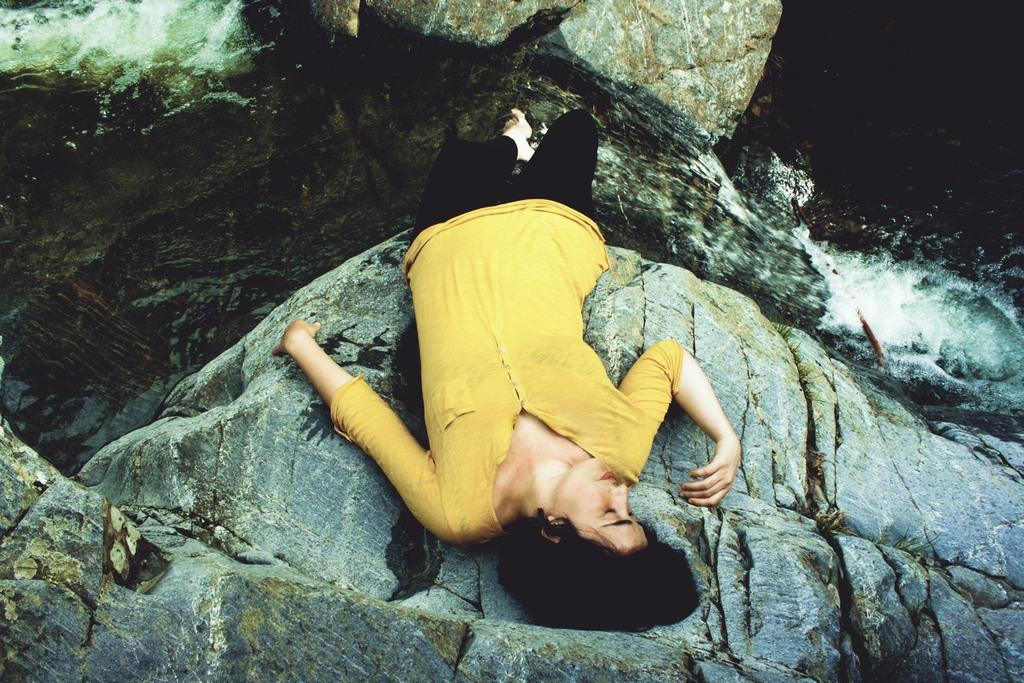Who is the main subject in the image? There is a woman in the image. What is the woman doing in the image? The woman is laying on a rock. What color is the woman's shirt in the image? The woman is wearing a yellow shirt. What color are the woman's pants in the image? The woman is wearing black pants. What can be seen in the background of the image? There is water visible in the image. What type of cough medicine is the woman holding in the image? There is no cough medicine present in the image; the woman is laying on a rock and wearing a yellow shirt and black pants. Is the woman a carpenter in the image? There is no indication in the image that the woman is a carpenter. 